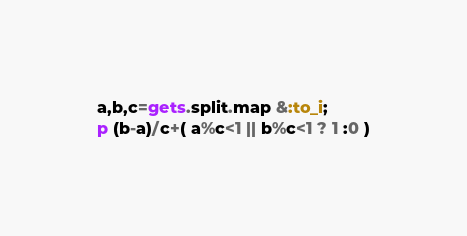<code> <loc_0><loc_0><loc_500><loc_500><_Ruby_>a,b,c=gets.split.map &:to_i;
p (b-a)/c+( a%c<1 || b%c<1 ? 1 :0 )</code> 